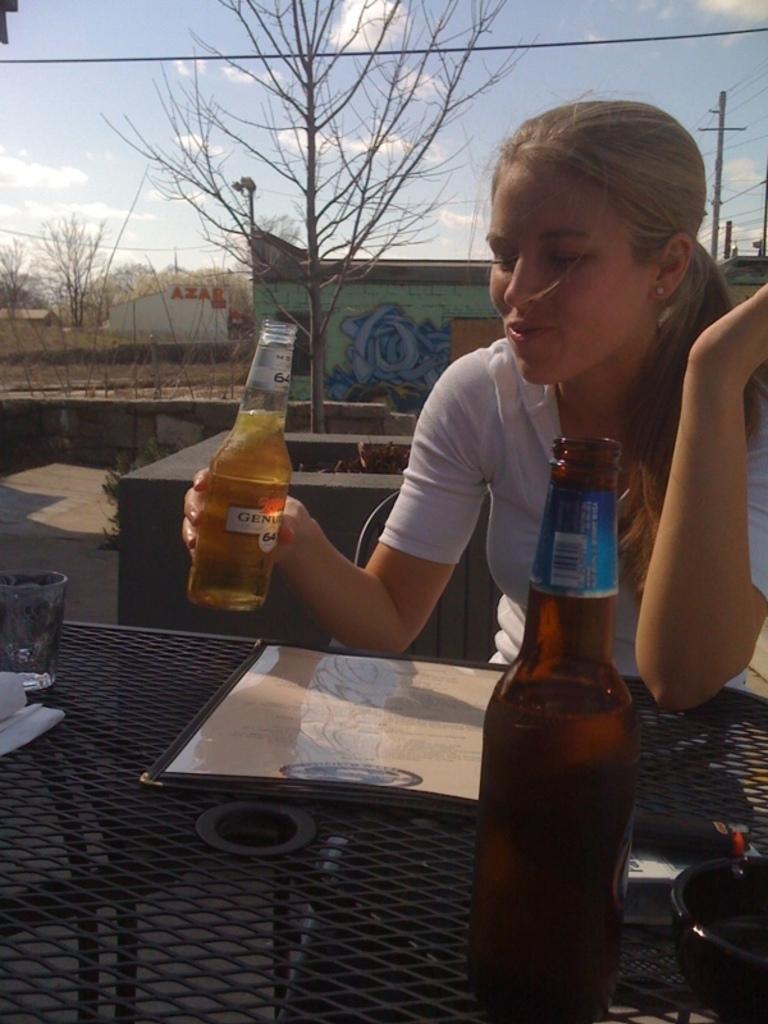Can you describe this image briefly? Bottom right side of the image a woman is holding a bottle. Bottom right side of the image there is a bottle on the table. Bottom left side of the image there is a glass on the table. In the middle of the image there is a bare tree. Behind the tree there is a sky and clouds. Top right side of the image there is a pole. 